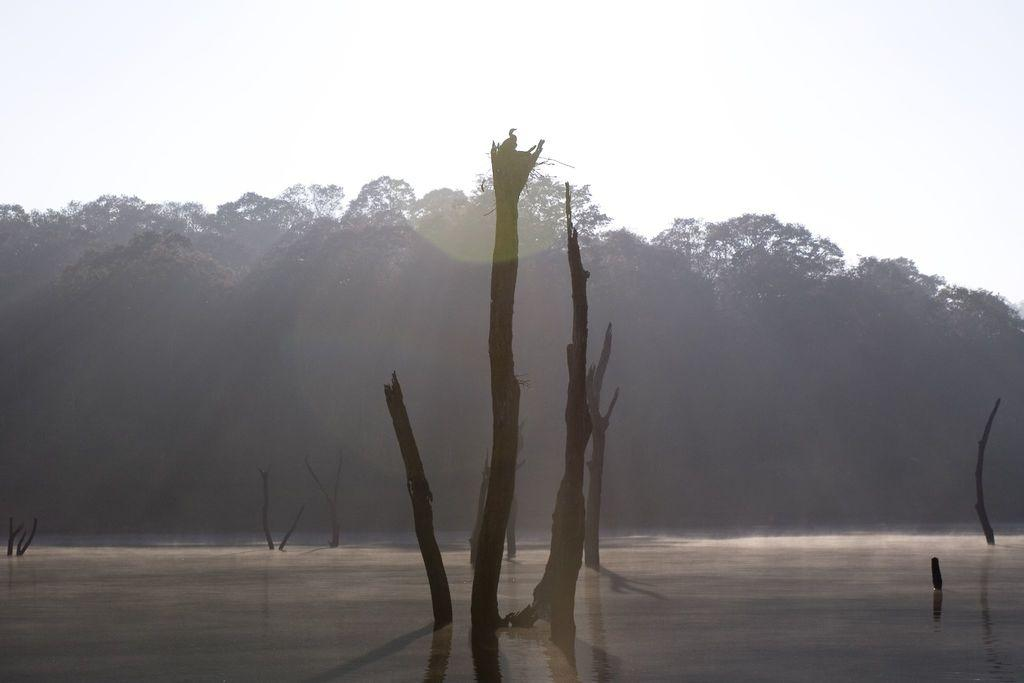What can be seen in the foreground of the picture? There is water and trunks of trees in the foreground of the picture. What else is visible in the foreground besides the water? There are trunks of trees in the foreground. What can be seen in the background of the picture? There are trees in the background of the picture. How would you describe the weather in the image? The sky is sunny, which suggests a clear and bright day. How many girls are holding a quilt in the image? There are no girls or quilts present in the image. What type of tooth can be seen in the image? There are no teeth or dental-related objects present in the image. 